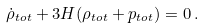Convert formula to latex. <formula><loc_0><loc_0><loc_500><loc_500>\dot { \rho } _ { t o t } + 3 H ( \rho _ { t o t } + p _ { t o t } ) = 0 \, .</formula> 